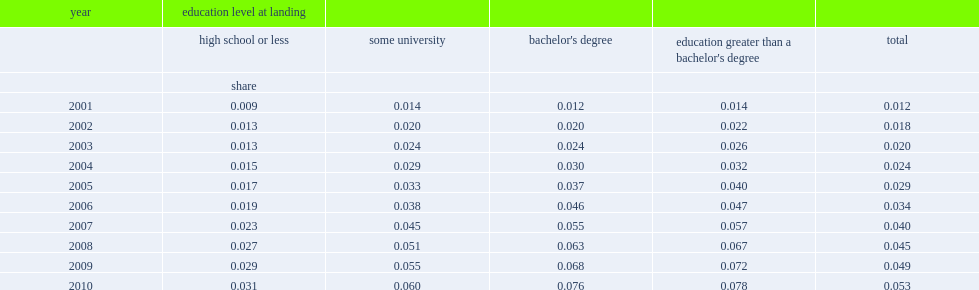Can you parse all the data within this table? {'header': ['year', 'education level at landing', '', '', '', ''], 'rows': [['', 'high school or less', 'some university', "bachelor's degree", "education greater than a bachelor's degree", 'total'], ['', 'share', '', '', '', ''], ['2001', '0.009', '0.014', '0.012', '0.014', '0.012'], ['2002', '0.013', '0.020', '0.020', '0.022', '0.018'], ['2003', '0.013', '0.024', '0.024', '0.026', '0.020'], ['2004', '0.015', '0.029', '0.030', '0.032', '0.024'], ['2005', '0.017', '0.033', '0.037', '0.040', '0.029'], ['2006', '0.019', '0.038', '0.046', '0.047', '0.034'], ['2007', '0.023', '0.045', '0.055', '0.057', '0.040'], ['2008', '0.027', '0.051', '0.063', '0.067', '0.045'], ['2009', '0.029', '0.055', '0.068', '0.072', '0.049'], ['2010', '0.031', '0.060', '0.076', '0.078', '0.053']]} What the number of high-school educated by 2010? 0.031. What the number of bachelor's degree holders educated by 2010? 0.076. 